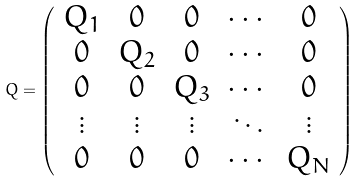<formula> <loc_0><loc_0><loc_500><loc_500>Q = \left ( \begin{array} { c c c c c } Q _ { 1 } & 0 & 0 & \cdots & 0 \\ 0 & Q _ { 2 } & 0 & \cdots & 0 \\ 0 & 0 & Q _ { 3 } & \cdots & 0 \\ \vdots & \vdots & \vdots & \ddots & \vdots \\ 0 & 0 & 0 & \cdots & Q _ { N } \end{array} \right )</formula> 